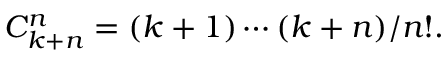Convert formula to latex. <formula><loc_0><loc_0><loc_500><loc_500>C _ { k + n } ^ { n } = ( k + 1 ) \cdots ( k + n ) / n ! .</formula> 